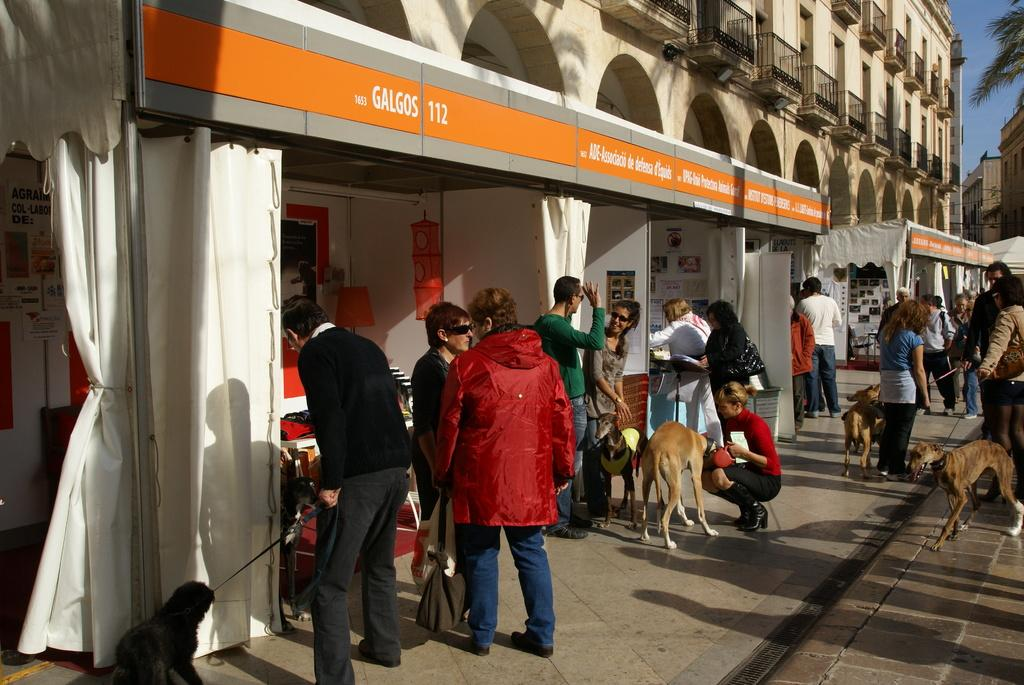What type of setting is depicted in the image? The image is an outdoor scene. What can be seen on the ground in the image? There are persons standing on a footpath. What animals are present in the image? There are dogs beside the persons. What type of structures can be seen in the image? There are stores visible in the image, and there is a building with a fence. Where is the library located in the image? There is no library present in the image. What type of pain are the persons experiencing in the image? There is no indication of pain or discomfort experienced by the persons in the image. 